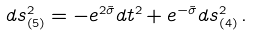<formula> <loc_0><loc_0><loc_500><loc_500>d s _ { ( 5 ) } ^ { 2 } = - e ^ { 2 \tilde { \sigma } } d t ^ { 2 } + e ^ { - \tilde { \sigma } } d s ^ { 2 } _ { ( 4 ) } \, .</formula> 